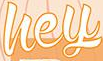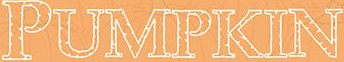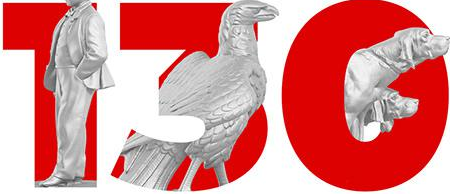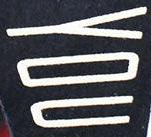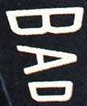What text appears in these images from left to right, separated by a semicolon? hey; PUMPKIN; 130; YOU; BAD 